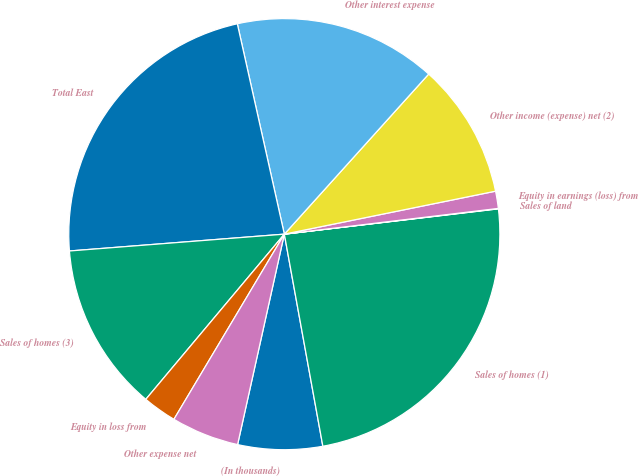Convert chart. <chart><loc_0><loc_0><loc_500><loc_500><pie_chart><fcel>(In thousands)<fcel>Sales of homes (1)<fcel>Sales of land<fcel>Equity in earnings (loss) from<fcel>Other income (expense) net (2)<fcel>Other interest expense<fcel>Total East<fcel>Sales of homes (3)<fcel>Equity in loss from<fcel>Other expense net<nl><fcel>6.34%<fcel>24.02%<fcel>0.03%<fcel>1.29%<fcel>10.13%<fcel>15.18%<fcel>22.75%<fcel>12.65%<fcel>2.55%<fcel>5.08%<nl></chart> 